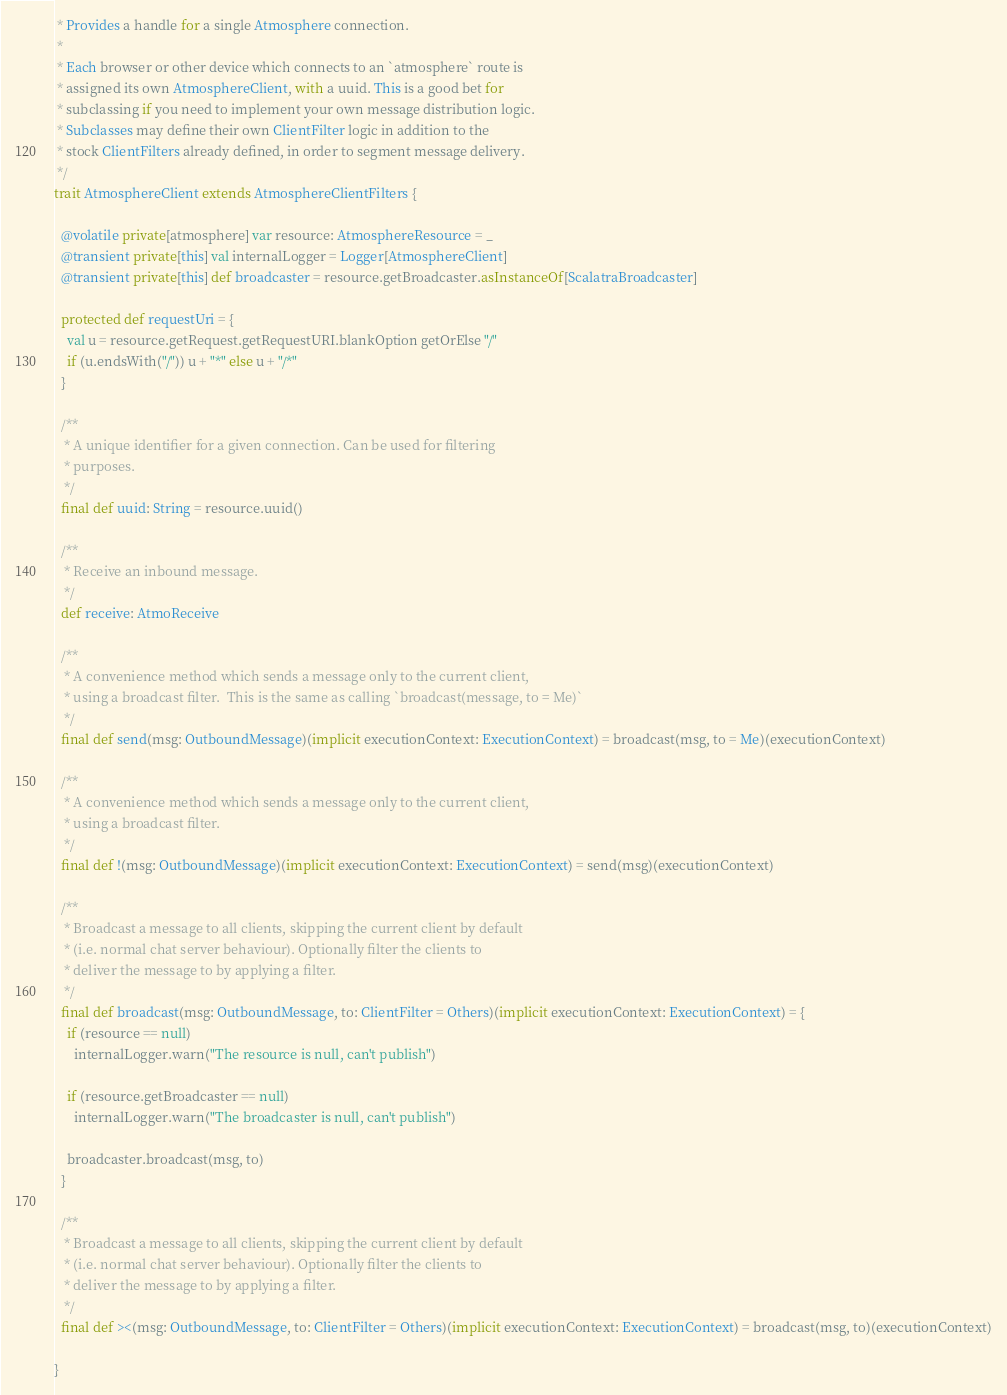<code> <loc_0><loc_0><loc_500><loc_500><_Scala_> * Provides a handle for a single Atmosphere connection. 
 * 
 * Each browser or other device which connects to an `atmosphere` route is
 * assigned its own AtmosphereClient, with a uuid. This is a good bet for
 * subclassing if you need to implement your own message distribution logic.
 * Subclasses may define their own ClientFilter logic in addition to the
 * stock ClientFilters already defined, in order to segment message delivery.
 */
trait AtmosphereClient extends AtmosphereClientFilters {

  @volatile private[atmosphere] var resource: AtmosphereResource = _
  @transient private[this] val internalLogger = Logger[AtmosphereClient]
  @transient private[this] def broadcaster = resource.getBroadcaster.asInstanceOf[ScalatraBroadcaster]

  protected def requestUri = {
    val u = resource.getRequest.getRequestURI.blankOption getOrElse "/"
    if (u.endsWith("/")) u + "*" else u + "/*"
  }

  /**
   * A unique identifier for a given connection. Can be used for filtering
   * purposes.
   */
  final def uuid: String = resource.uuid()

  /**
   * Receive an inbound message.
   */
  def receive: AtmoReceive

  /**
   * A convenience method which sends a message only to the current client,
   * using a broadcast filter.  This is the same as calling `broadcast(message, to = Me)`
   */
  final def send(msg: OutboundMessage)(implicit executionContext: ExecutionContext) = broadcast(msg, to = Me)(executionContext)

  /**
   * A convenience method which sends a message only to the current client,
   * using a broadcast filter.
   */
  final def !(msg: OutboundMessage)(implicit executionContext: ExecutionContext) = send(msg)(executionContext)

  /**
   * Broadcast a message to all clients, skipping the current client by default
   * (i.e. normal chat server behaviour). Optionally filter the clients to
   * deliver the message to by applying a filter.
   */
  final def broadcast(msg: OutboundMessage, to: ClientFilter = Others)(implicit executionContext: ExecutionContext) = {
    if (resource == null)
      internalLogger.warn("The resource is null, can't publish")

    if (resource.getBroadcaster == null)
      internalLogger.warn("The broadcaster is null, can't publish")

    broadcaster.broadcast(msg, to)
  }

  /**
   * Broadcast a message to all clients, skipping the current client by default
   * (i.e. normal chat server behaviour). Optionally filter the clients to
   * deliver the message to by applying a filter.
   */
  final def ><(msg: OutboundMessage, to: ClientFilter = Others)(implicit executionContext: ExecutionContext) = broadcast(msg, to)(executionContext)

}
</code> 